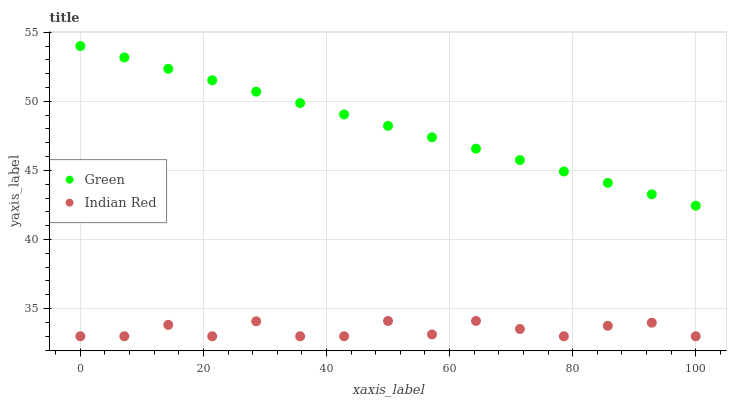Does Indian Red have the minimum area under the curve?
Answer yes or no. Yes. Does Green have the maximum area under the curve?
Answer yes or no. Yes. Does Indian Red have the maximum area under the curve?
Answer yes or no. No. Is Green the smoothest?
Answer yes or no. Yes. Is Indian Red the roughest?
Answer yes or no. Yes. Is Indian Red the smoothest?
Answer yes or no. No. Does Indian Red have the lowest value?
Answer yes or no. Yes. Does Green have the highest value?
Answer yes or no. Yes. Does Indian Red have the highest value?
Answer yes or no. No. Is Indian Red less than Green?
Answer yes or no. Yes. Is Green greater than Indian Red?
Answer yes or no. Yes. Does Indian Red intersect Green?
Answer yes or no. No. 